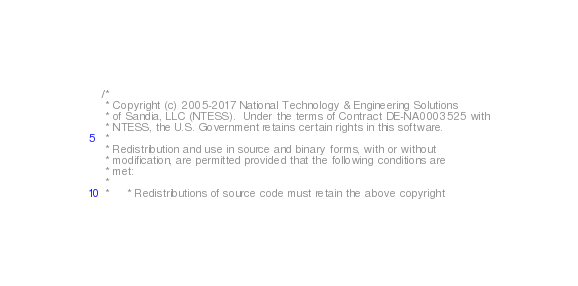<code> <loc_0><loc_0><loc_500><loc_500><_C_>/*
 * Copyright (c) 2005-2017 National Technology & Engineering Solutions
 * of Sandia, LLC (NTESS).  Under the terms of Contract DE-NA0003525 with
 * NTESS, the U.S. Government retains certain rights in this software.
 *
 * Redistribution and use in source and binary forms, with or without
 * modification, are permitted provided that the following conditions are
 * met:
 *
 *     * Redistributions of source code must retain the above copyright</code> 